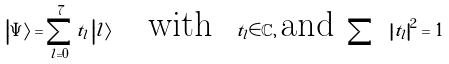<formula> <loc_0><loc_0><loc_500><loc_500>\left | \Psi \right \rangle = \sum _ { l = 0 } ^ { 7 } t _ { l } \left | l \right \rangle \text {\quad with \ } t _ { l } \in \mathbb { C } , \, \text {and } \sum \text { } \left | t _ { l } \right | ^ { 2 } = 1</formula> 